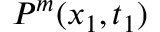Convert formula to latex. <formula><loc_0><loc_0><loc_500><loc_500>P ^ { m } ( x _ { 1 } , t _ { 1 } )</formula> 